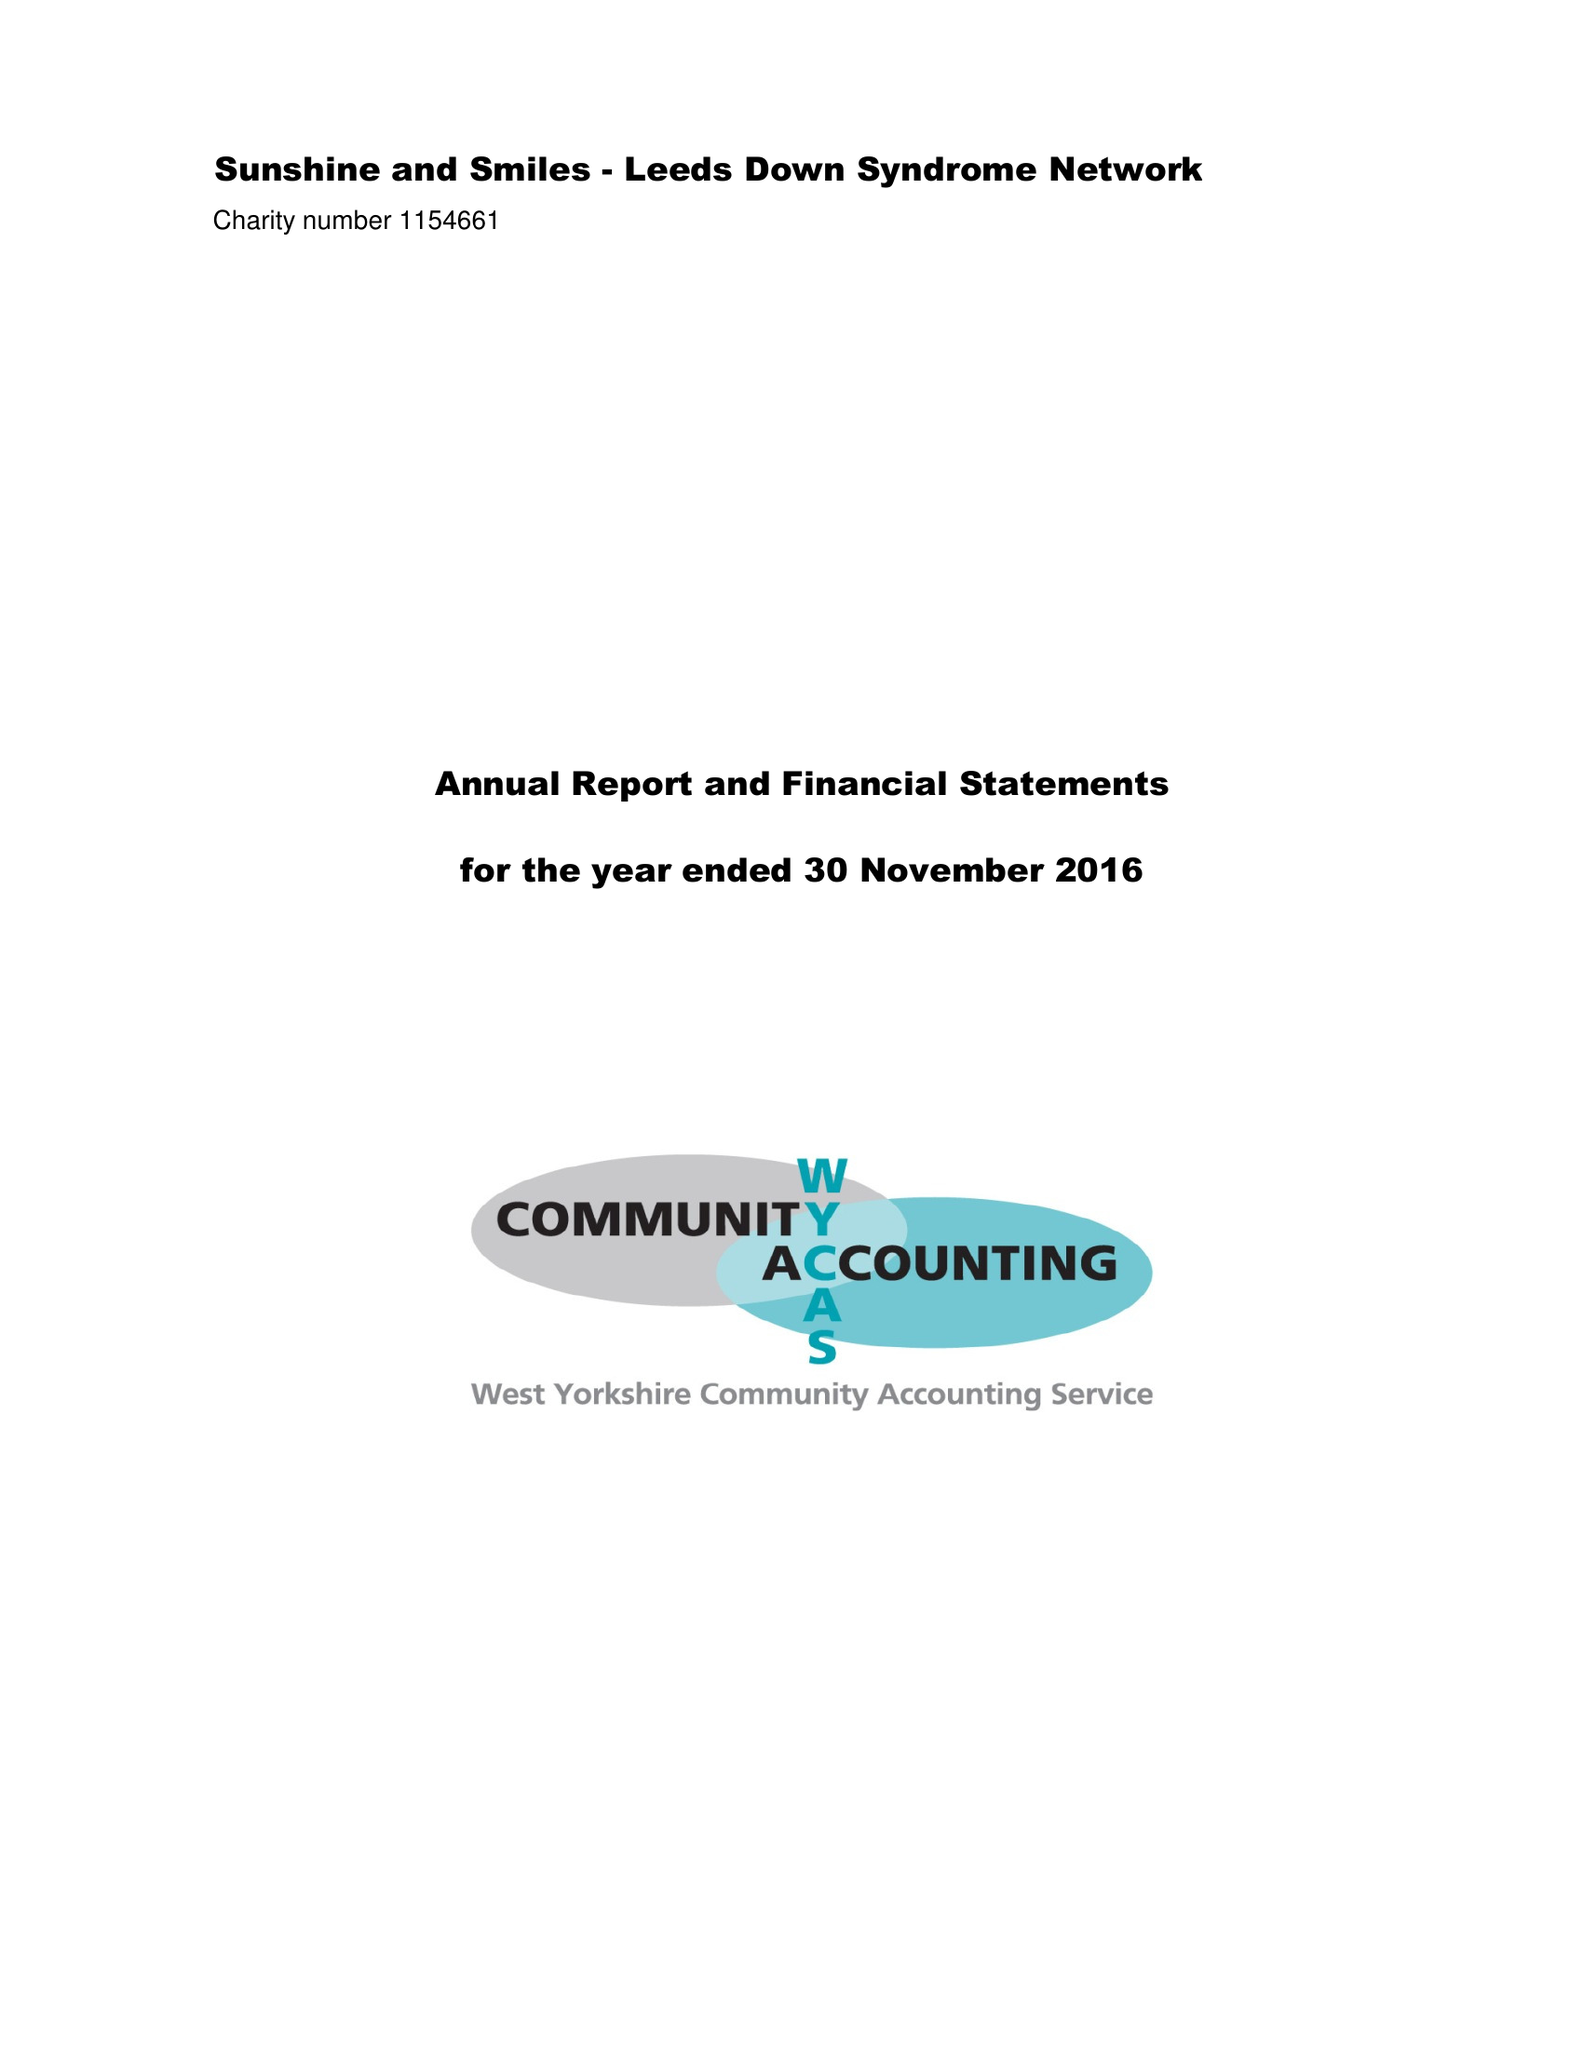What is the value for the spending_annually_in_british_pounds?
Answer the question using a single word or phrase. 64045.00 